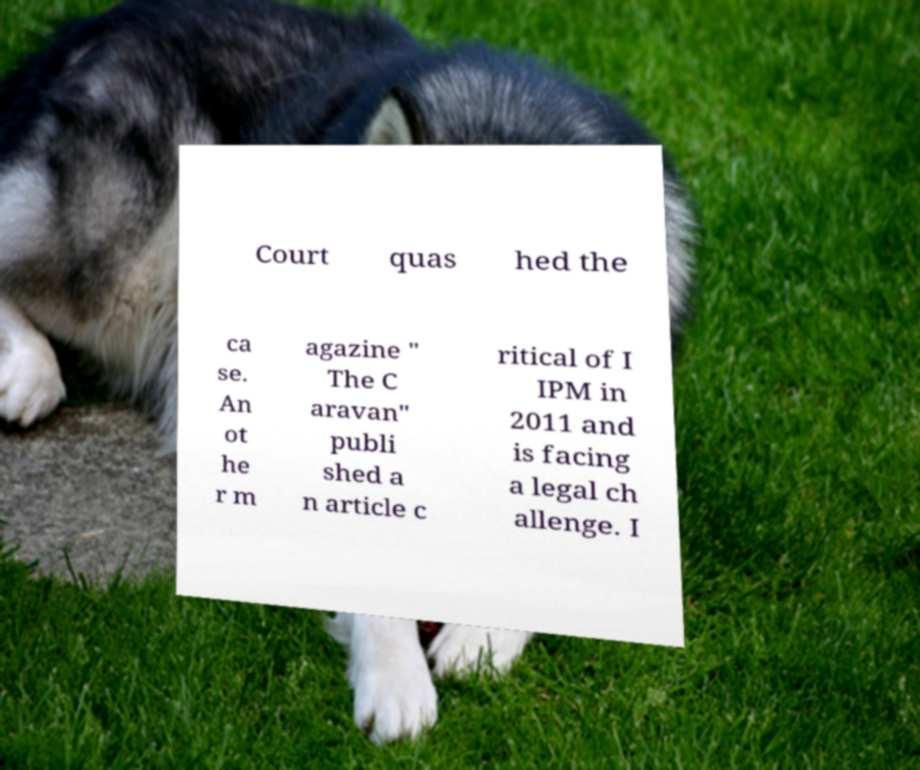Could you assist in decoding the text presented in this image and type it out clearly? Court quas hed the ca se. An ot he r m agazine " The C aravan" publi shed a n article c ritical of I IPM in 2011 and is facing a legal ch allenge. I 